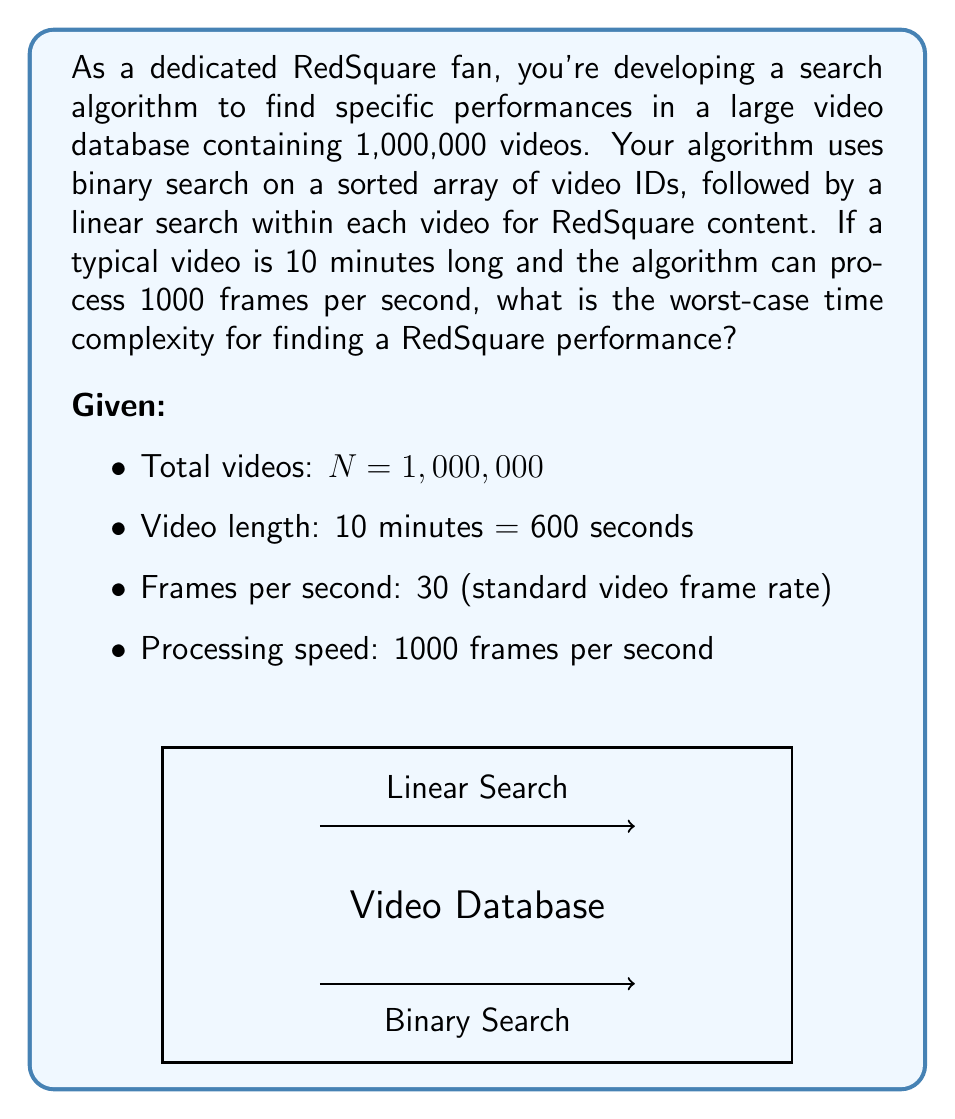Teach me how to tackle this problem. Let's break this down step-by-step:

1) Binary search complexity:
   The worst-case time complexity for binary search is $O(\log_2 N)$.
   $$O(\log_2 1,000,000) \approx O(20)$$

2) Linear search within a video:
   - Frames in a video = 600 seconds * 30 frames/second = 18,000 frames
   - Time to process one video = 18,000 frames / 1000 frames/second = 18 seconds
   - This is a constant time operation, so it's $O(1)$ in terms of N

3) Combine the complexities:
   For each step of the binary search, we might need to perform the linear search.
   Total complexity = $O(\log_2 N) * O(1) = O(\log_2 N)$

4) Express in Big O notation:
   The worst-case time complexity is $O(\log N)$, where N is the number of videos.

Note: While the constant factors (18 seconds per video) are significant in practice, they don't affect the asymptotic complexity in Big O notation.
Answer: $O(\log N)$ 